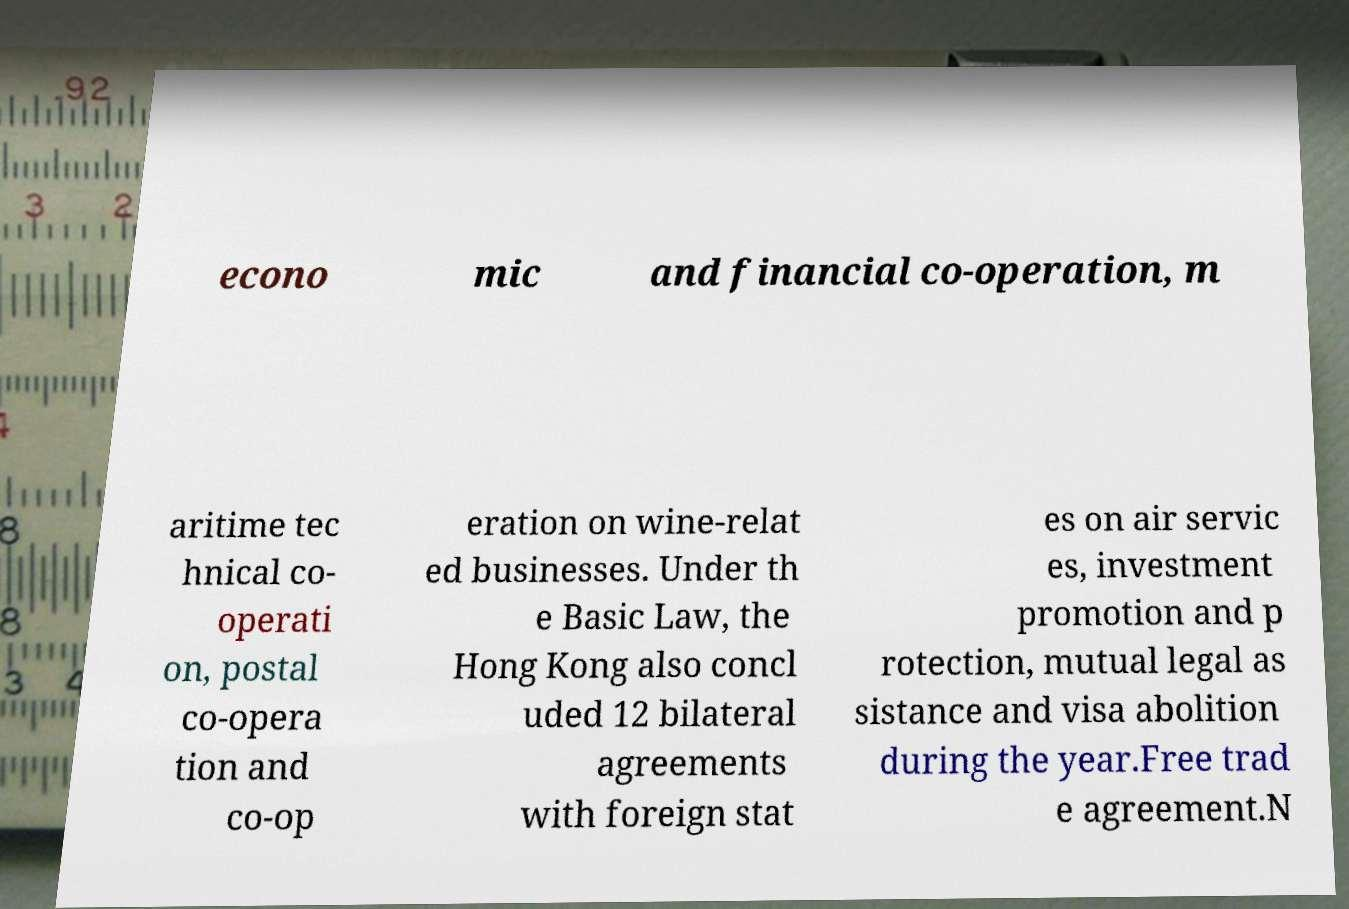Could you assist in decoding the text presented in this image and type it out clearly? econo mic and financial co-operation, m aritime tec hnical co- operati on, postal co-opera tion and co-op eration on wine-relat ed businesses. Under th e Basic Law, the Hong Kong also concl uded 12 bilateral agreements with foreign stat es on air servic es, investment promotion and p rotection, mutual legal as sistance and visa abolition during the year.Free trad e agreement.N 